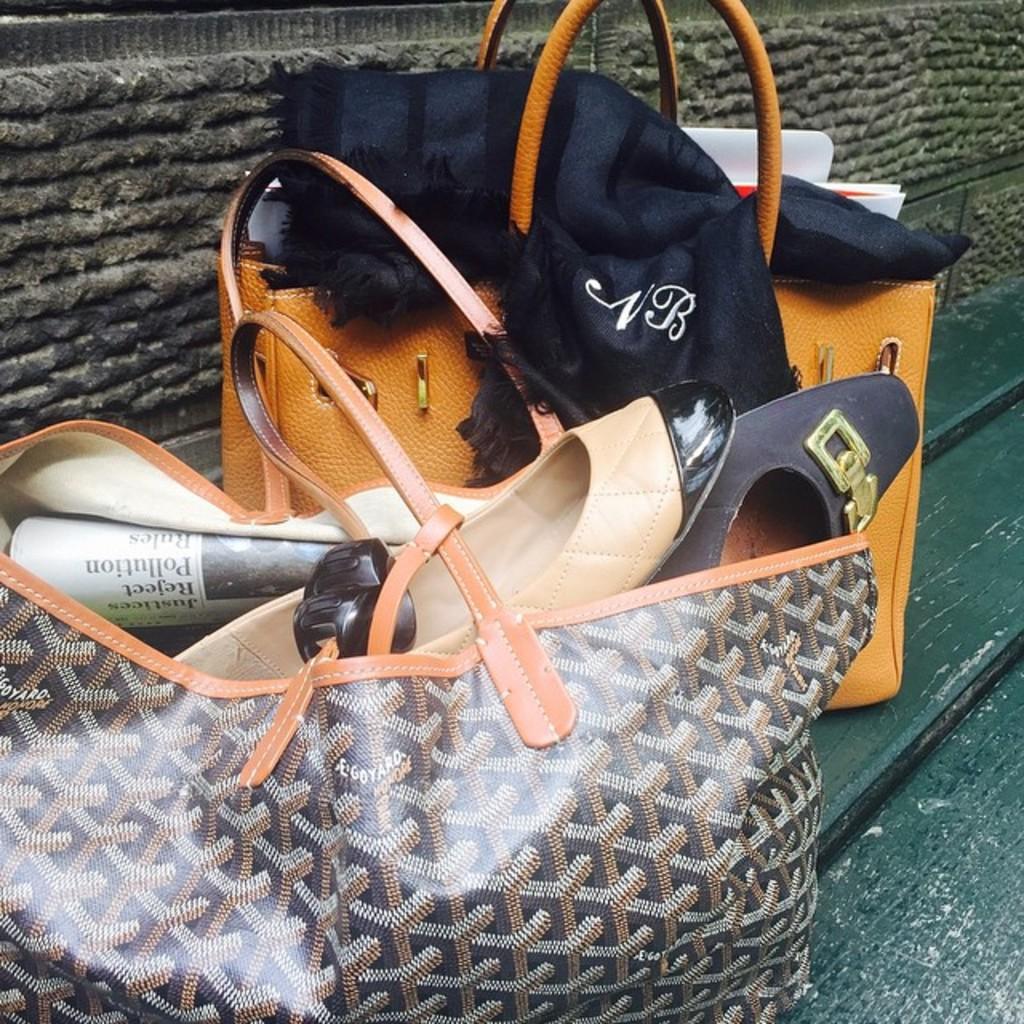Can you describe this image briefly? In this image I can see two handbags on the bench. In the hand bag there are shoes and a papers. 